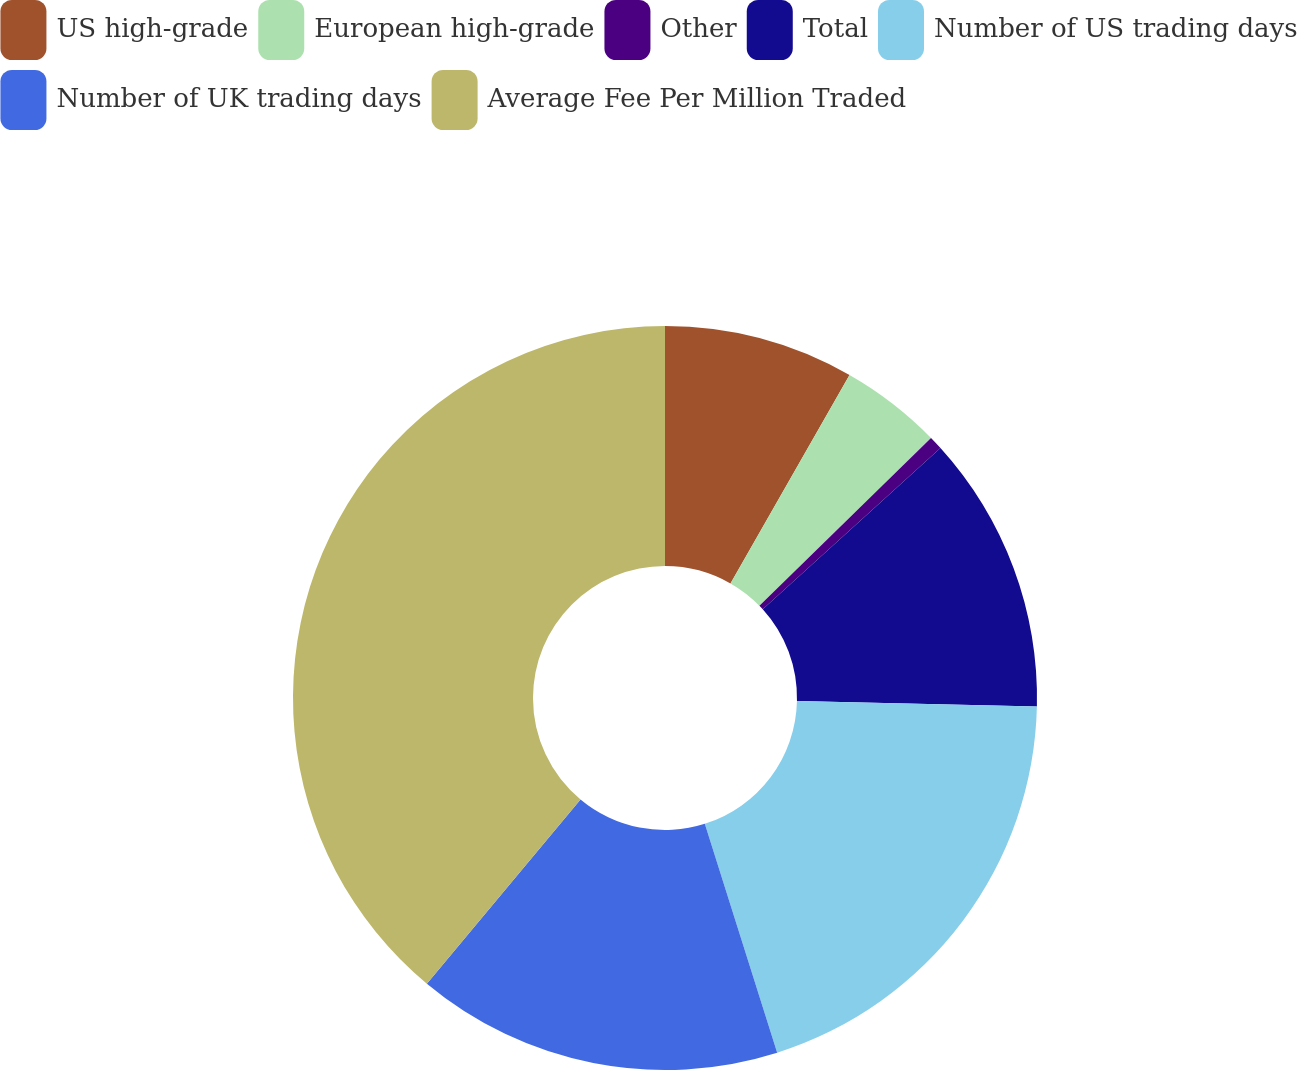Convert chart. <chart><loc_0><loc_0><loc_500><loc_500><pie_chart><fcel>US high-grade<fcel>European high-grade<fcel>Other<fcel>Total<fcel>Number of US trading days<fcel>Number of UK trading days<fcel>Average Fee Per Million Traded<nl><fcel>8.26%<fcel>4.42%<fcel>0.59%<fcel>12.09%<fcel>19.76%<fcel>15.93%<fcel>38.94%<nl></chart> 